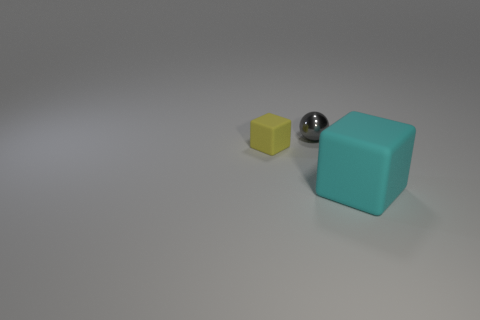Add 1 tiny cyan rubber cylinders. How many objects exist? 4 Subtract all spheres. How many objects are left? 2 Add 1 cyan rubber cylinders. How many cyan rubber cylinders exist? 1 Subtract 0 green balls. How many objects are left? 3 Subtract all tiny cyan balls. Subtract all spheres. How many objects are left? 2 Add 1 big cyan blocks. How many big cyan blocks are left? 2 